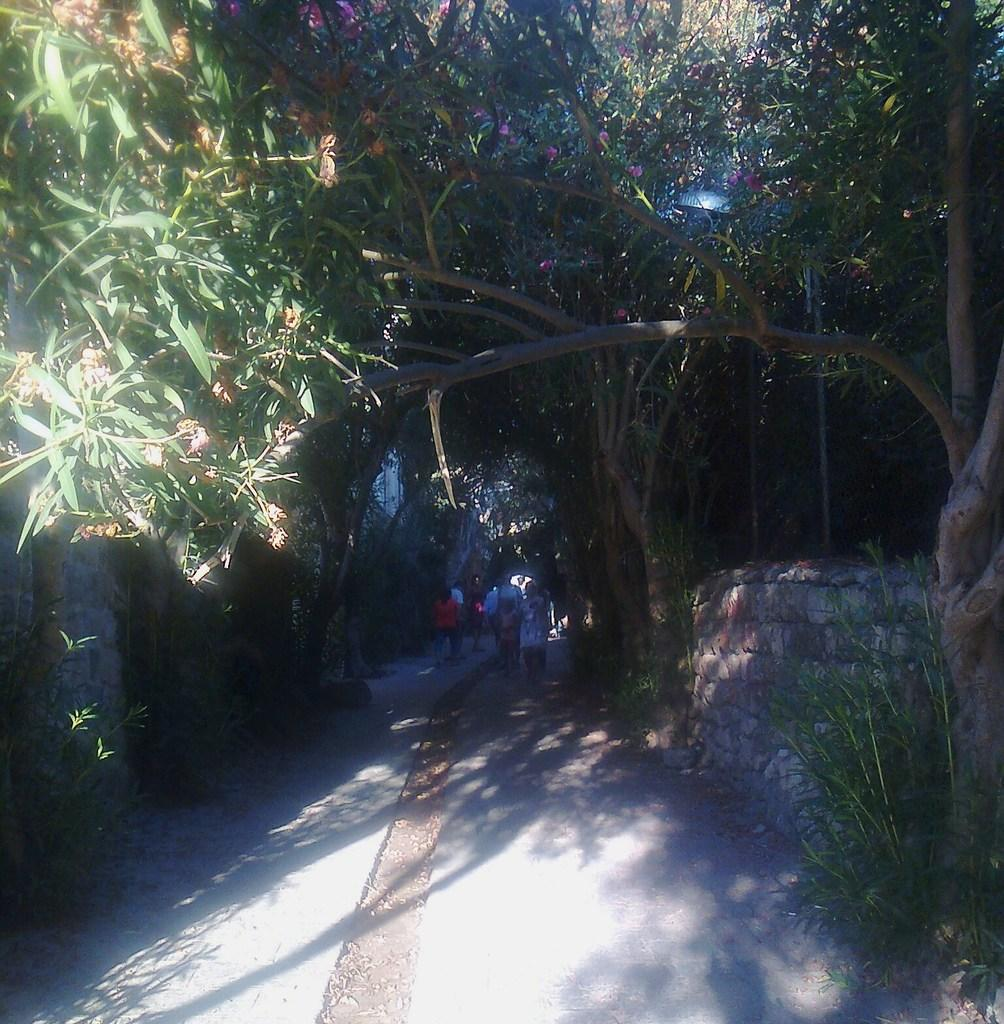What are the people in the image doing? The people in the image are walking. What can be seen in the background of the image? There are trees visible in the background of the image. What type of hair is visible on the trees in the image? There is no hair present on the trees in the image; they are simply trees with leaves or branches. 